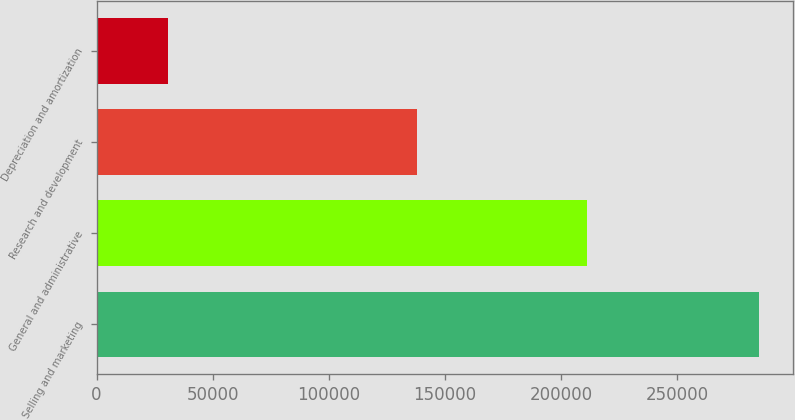<chart> <loc_0><loc_0><loc_500><loc_500><bar_chart><fcel>Selling and marketing<fcel>General and administrative<fcel>Research and development<fcel>Depreciation and amortization<nl><fcel>285453<fcel>211409<fcel>137915<fcel>30707<nl></chart> 